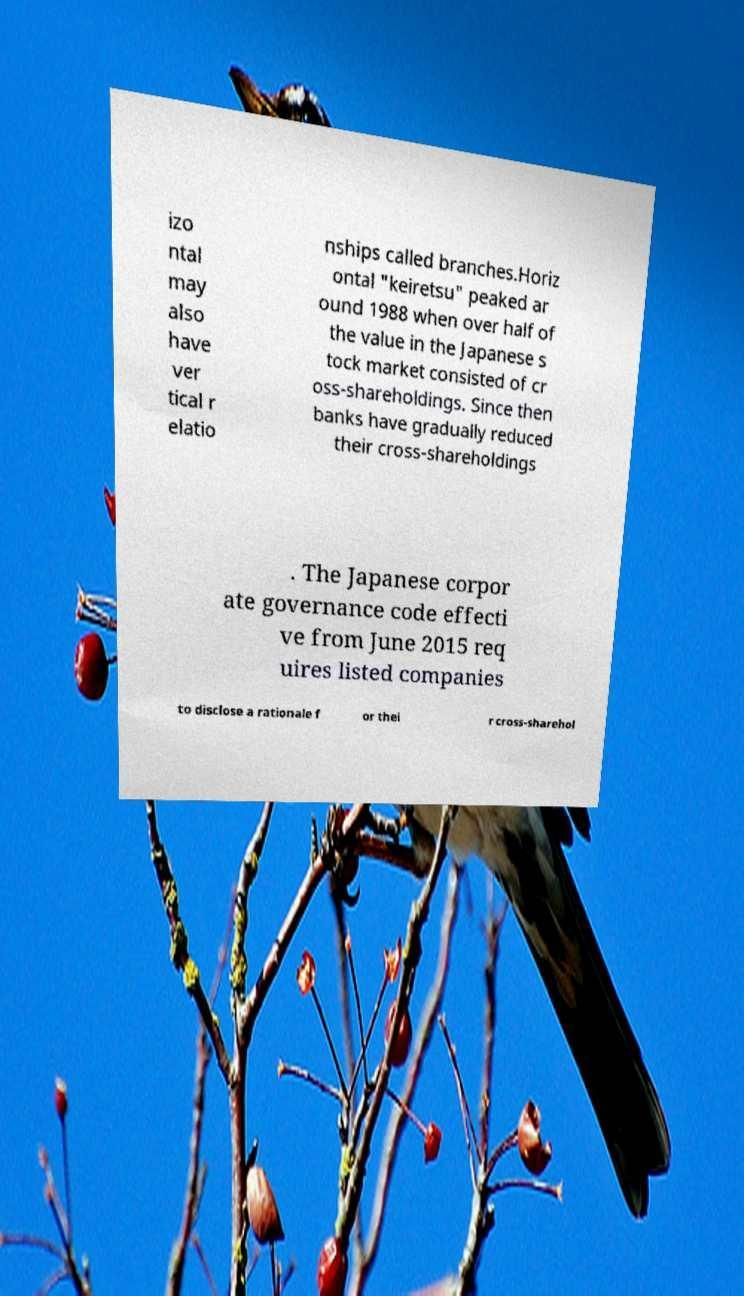For documentation purposes, I need the text within this image transcribed. Could you provide that? izo ntal may also have ver tical r elatio nships called branches.Horiz ontal "keiretsu" peaked ar ound 1988 when over half of the value in the Japanese s tock market consisted of cr oss-shareholdings. Since then banks have gradually reduced their cross-shareholdings . The Japanese corpor ate governance code effecti ve from June 2015 req uires listed companies to disclose a rationale f or thei r cross-sharehol 